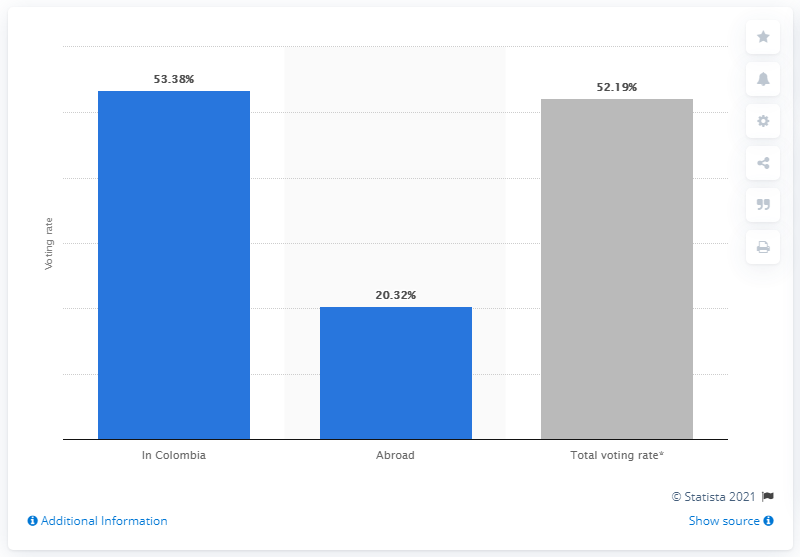Outline some significant characteristics in this image. In the 2018 presidential election in Colombia, 53.38% of the total number of registered voters cast a vote. The voting rate outside of Colombia was 20.32%. 